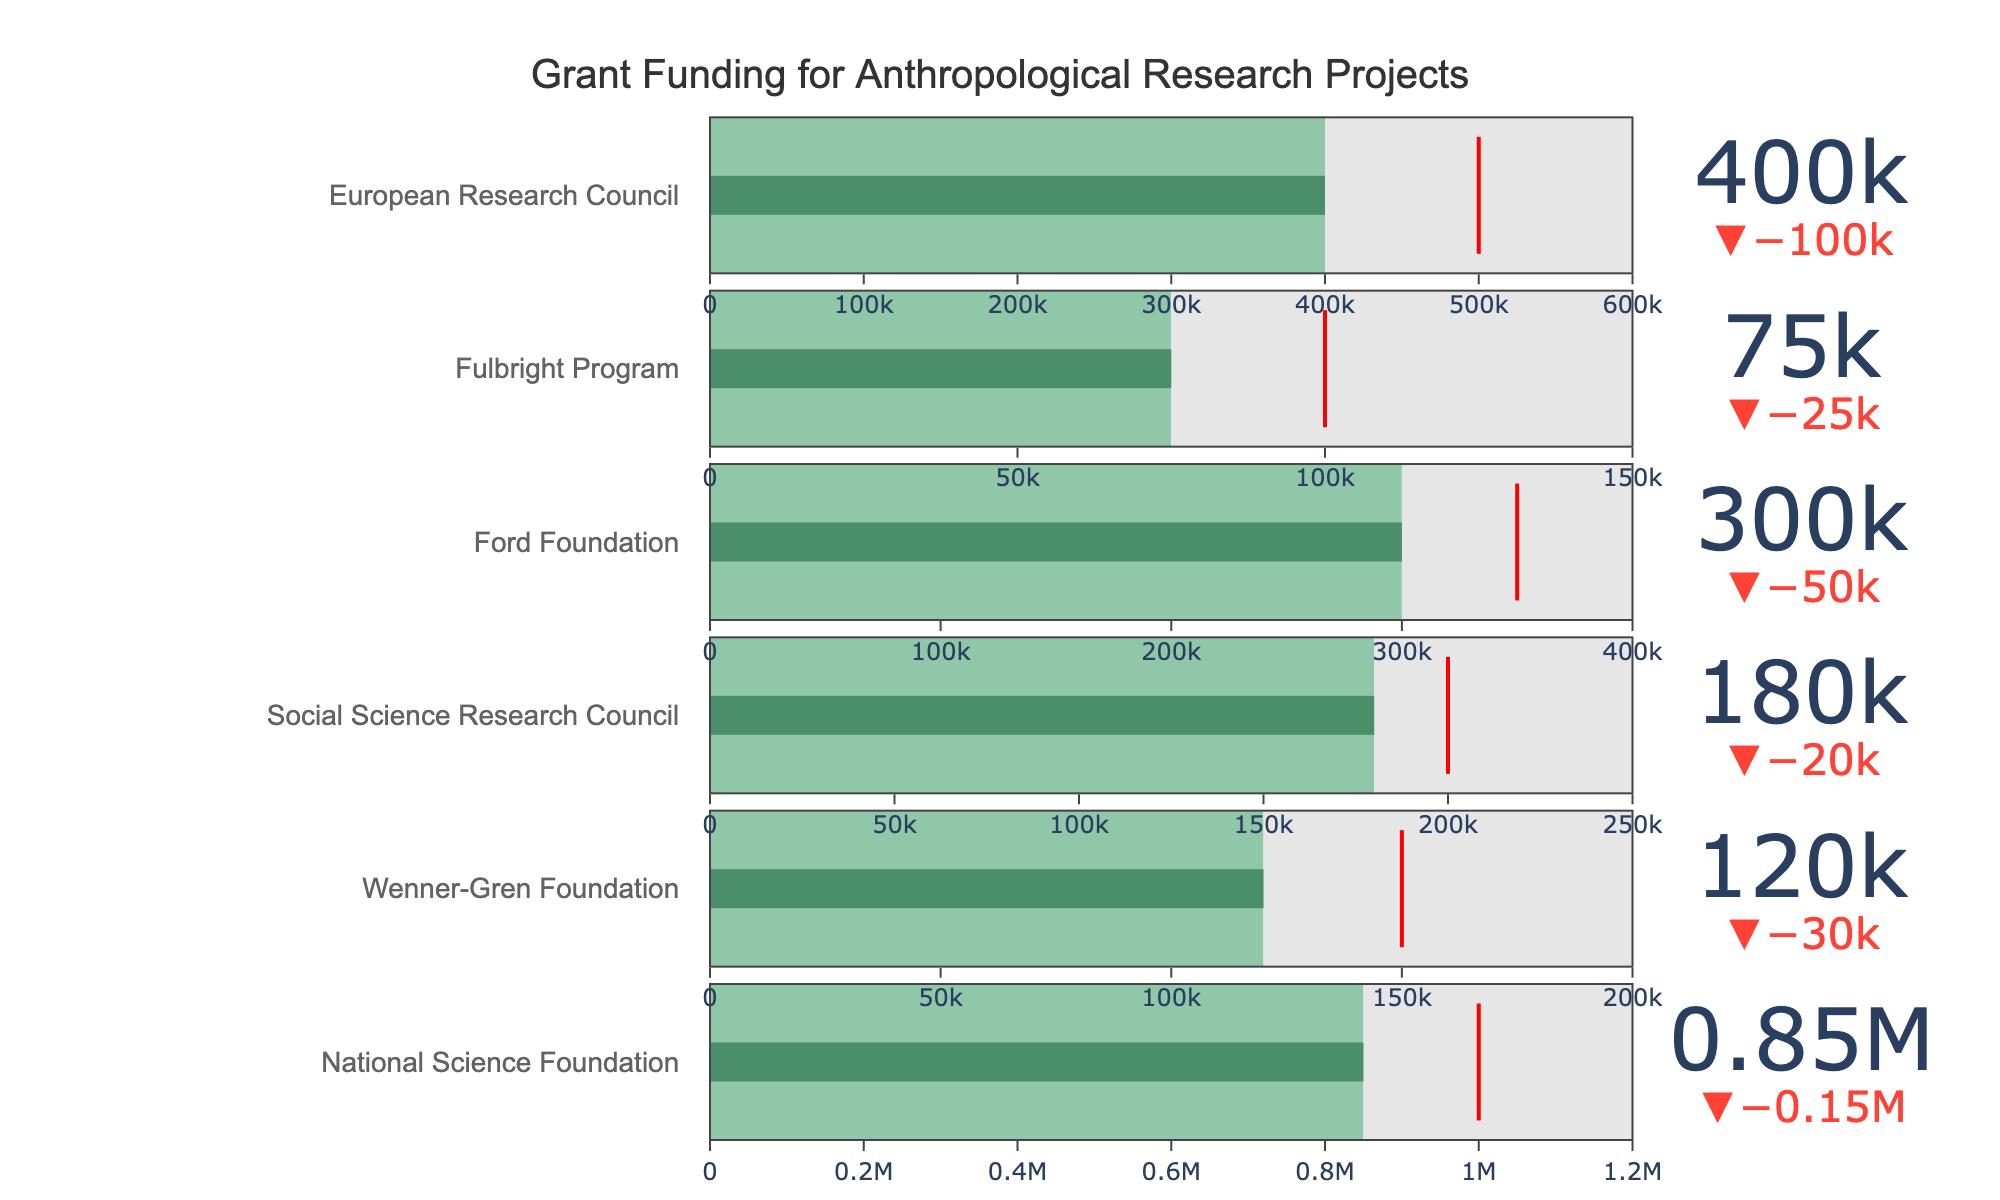What is the main title of the chart? The title of the chart is generally prominent and located at the top or center of the figure. Look at the top center of the chart to find the text.
Answer: Grant Funding for Anthropological Research Projects What is the actual funding amount received from the National Science Foundation? The green portion of the bar representing the National Science Foundation shows the actual funding amount.
Answer: 850,000 Which funding source had the highest target funding? Compare the red threshold markers for each funding source, which represent the target funding amounts. The European Research Council has the highest target funding at 500,000.
Answer: European Research Council How much more actual funding did the Ford Foundation receive compared to the Fulbright Program? Subtract the actual funding received by the Fulbright Program from that received by the Ford Foundation: 300,000 - 75,000 = 225,000.
Answer: 225,000 Did the Wenner-Gren Foundation meet its target funding? Check if the green portion (actual funding) of the Wenner-Gren Foundation’s bar reaches or exceeds the red threshold marker (target funding). It did not meet its target funding, as 120,000 is less than 150,000.
Answer: No Which funding source came closest to meeting its target funding without exceeding it? Look for the bar where the green portion is closest to the red threshold marker without going beyond it. The Social Science Research Council received 180,000 compared to its target of 200,000, making it the closest without exceeding.
Answer: Social Science Research Council What is the total actual funding from all sources combined? Add the actual funding amounts from all sources: 850,000 + 120,000 + 180,000 + 300,000 + 75,000 + 400,000 = 1,925,000.
Answer: 1,925,000 Which funding source surpassed its target funding by the highest margin? Calculate the difference between the actual funding and target funding for each source, and find the largest positive difference. The National Science Foundation had a target of 1,000,000 and an actual of 850,000, so it did not surpass. The biggest positive difference is for the Ford Foundation (50,000 above its target).
Answer: Ford Foundation Is the threshold value for any funding source equal to its maximum funding limit? Check if the red threshold marker (target funding) equals the end of the gray bar (maximum funding) for each data source. No source has its target funding equal to the maximum funding.
Answer: No What percentage of the maximum funding did the European Research Council receive? Divide the actual funding by the maximum funding and multiply by 100: (400,000 / 600,000) * 100 = 66.67%.
Answer: 66.67% 